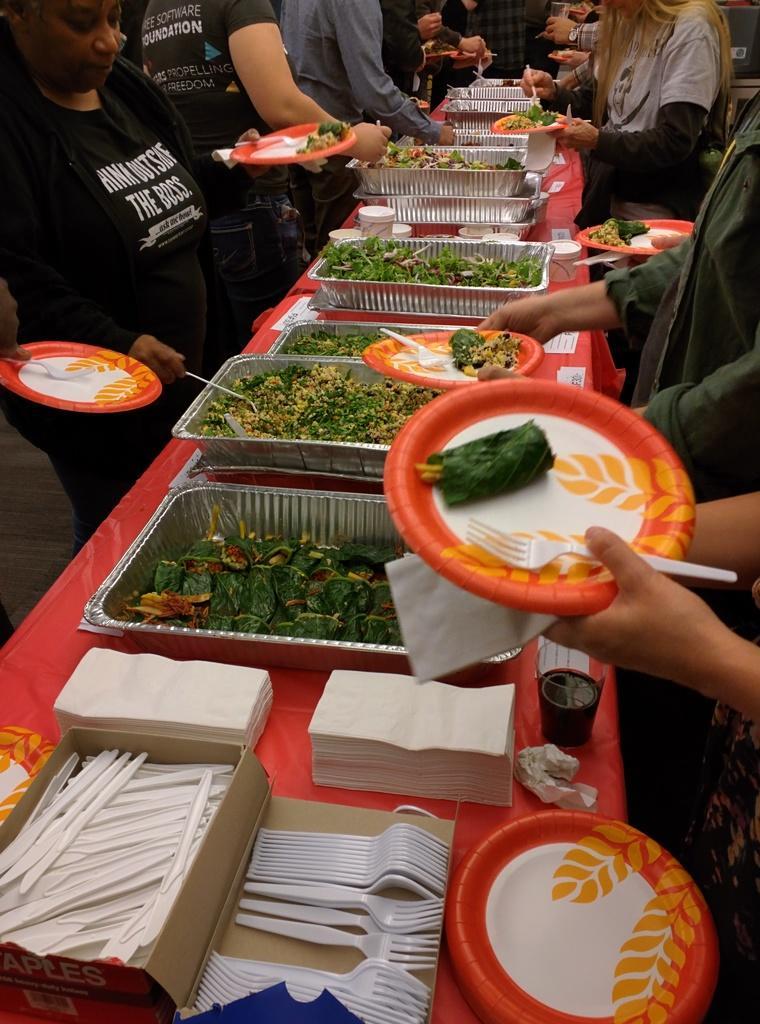In one or two sentences, can you explain what this image depicts? In the foreground of this image, there are trays with food, tissues, forks, spoons in the cardboard box and platters on the table and the persons are standing around the table holding platters and forks in their hands. 